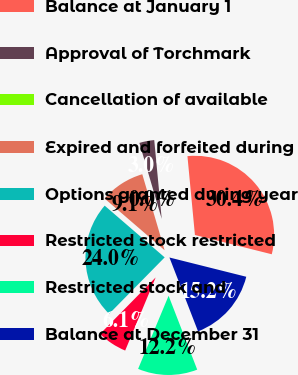Convert chart to OTSL. <chart><loc_0><loc_0><loc_500><loc_500><pie_chart><fcel>Balance at January 1<fcel>Approval of Torchmark<fcel>Cancellation of available<fcel>Expired and forfeited during<fcel>Options granted during year<fcel>Restricted stock restricted<fcel>Restricted stock and<fcel>Balance at December 31<nl><fcel>30.42%<fcel>3.04%<fcel>0.0%<fcel>9.13%<fcel>23.96%<fcel>6.08%<fcel>12.17%<fcel>15.21%<nl></chart> 